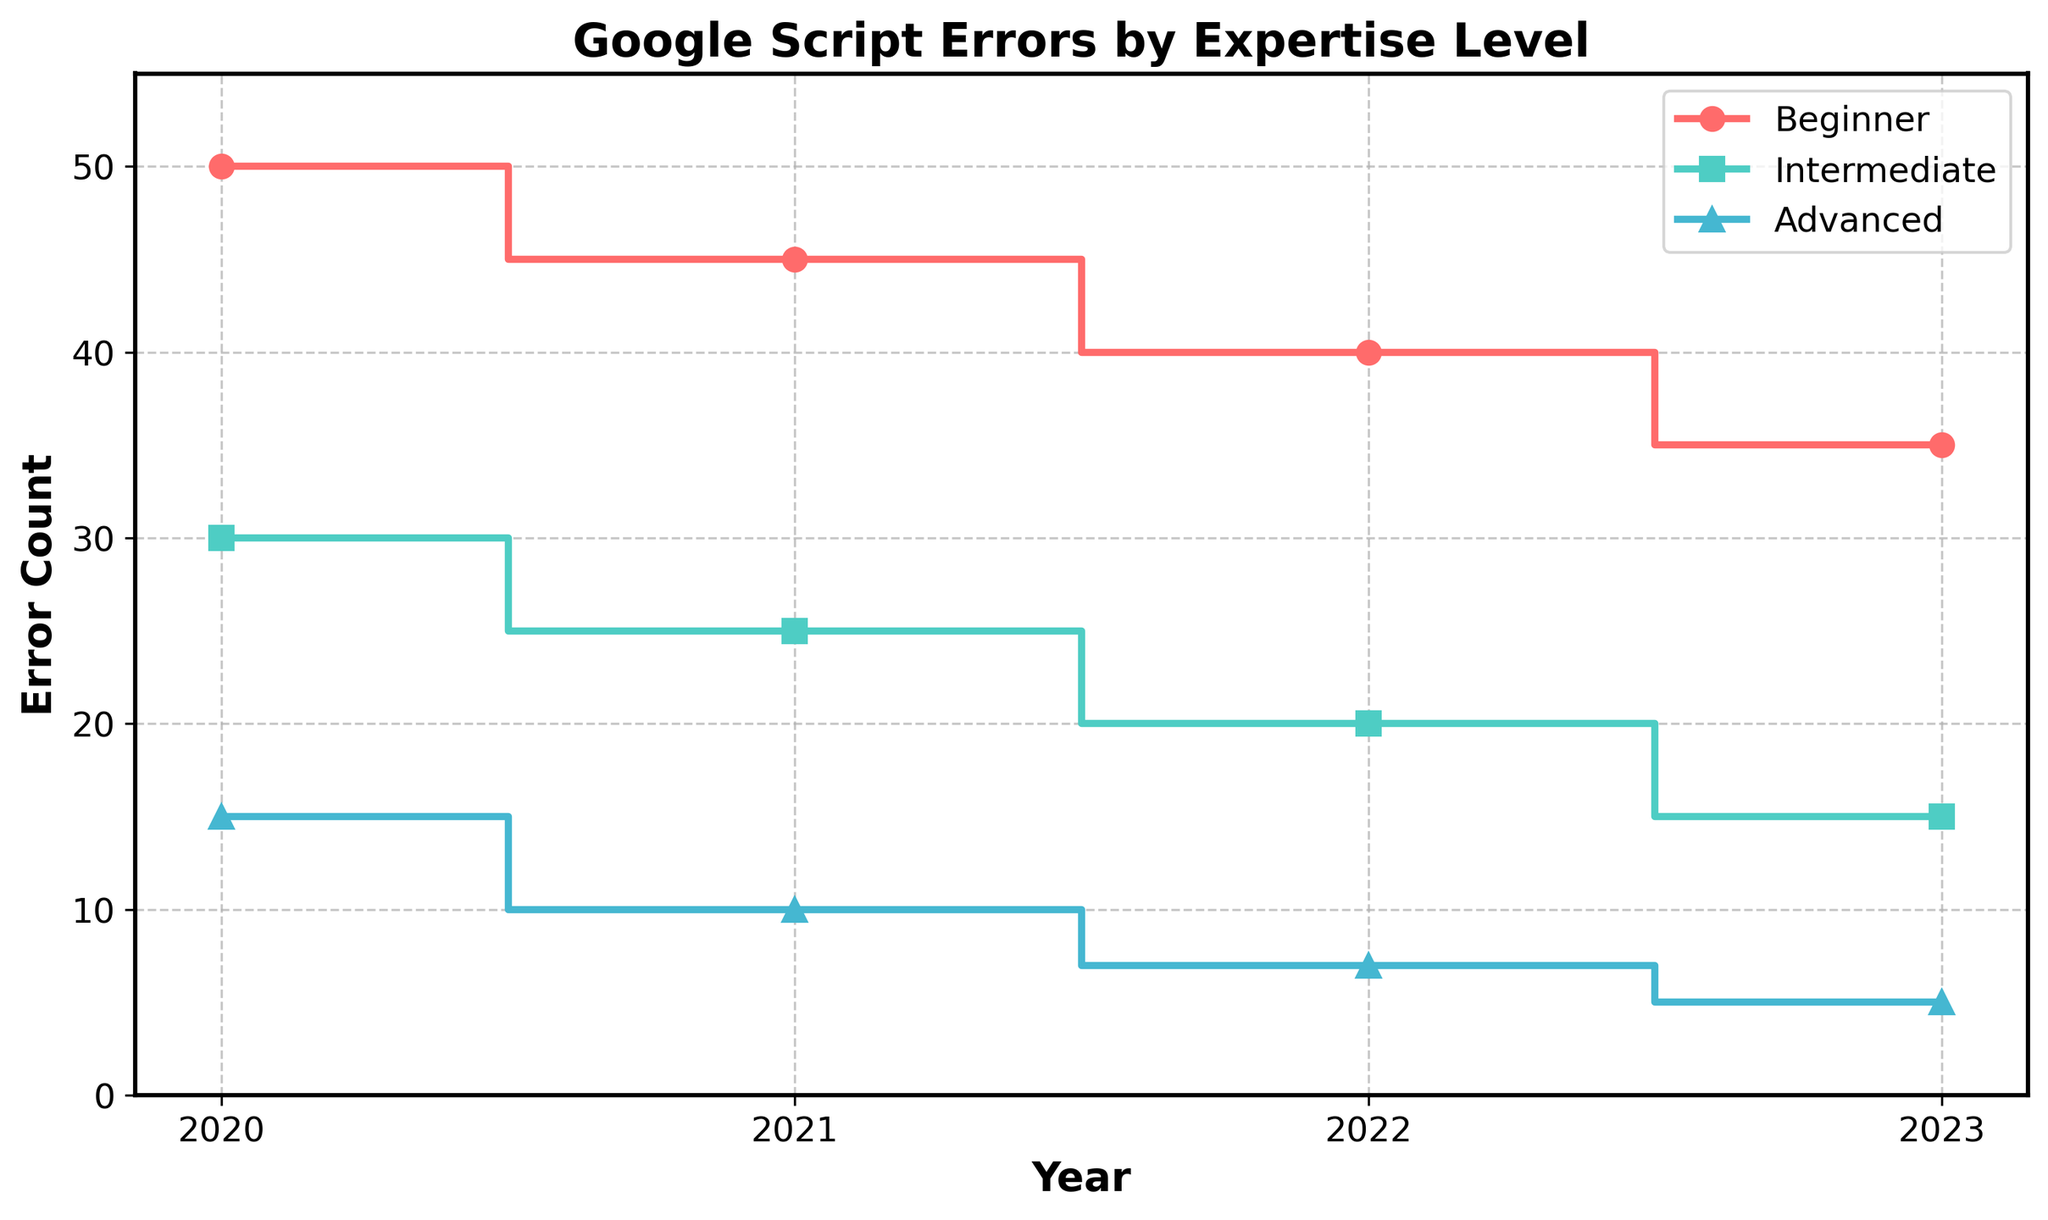What is the title of the figure? The title is typically displayed at the top of the plot. In this plot, it is "Google Script Errors by Expertise Level."
Answer: Google Script Errors by Expertise Level Which expertise level had the highest error count in 2020? In 2020, the data shows that beginners encountered 50 errors, which is higher compared to intermediate (30) and advanced (15) users.
Answer: Beginner How does the number of errors for beginners change from 2020 to 2023? The number of errors for beginners decreases over the years. In 2020, there were 50 errors, which decreased annually to 45 (2021), 40 (2022), and 35 (2023).
Answer: Decreases from 50 to 35 What was the difference in error counts between advanced and intermediate levels in 2021? For 2021, intermediate users had 25 errors, while advanced users had 10 errors. The difference is 25 - 10 = 15.
Answer: 15 By how much did the error count for intermediate users drop from 2020 to 2023? The error count for intermediate users dropped from 30 in 2020 to 15 in 2023. The difference is 30 - 15 = 15.
Answer: 15 Which expertise level experienced the largest drop in error counts from 2020 to 2023? Beginner users saw a drop from 50 to 35 (15 errors), intermediate users from 30 to 15 (15 errors), and advanced users from 15 to 5 (10 errors). So, both beginners and intermediate users experienced the largest drop.
Answer: Beginner and Intermediate What is the trend for advanced users' error counts over time? The number of errors for advanced users steadily decreases each year from 15 in 2020 to 5 in 2023.
Answer: Decreasing Compare the error count trends for beginners and advanced users from 2020 to 2023. Beginners show a gradual decrease from 50 to 35 errors, while advanced users also show a steady decline from 15 to 5. Both trends indicate a reduction, but the decline for beginners is less steep quantitatively.
Answer: Both have a decreasing trend, but beginners decline is less steep quantitatively How many total errors were encountered by all users in 2022? Sum the errors for all expertise levels in 2022: beginners (40) + intermediate (20) + advanced (7). The total is 40 + 20 + 7 = 67.
Answer: 67 